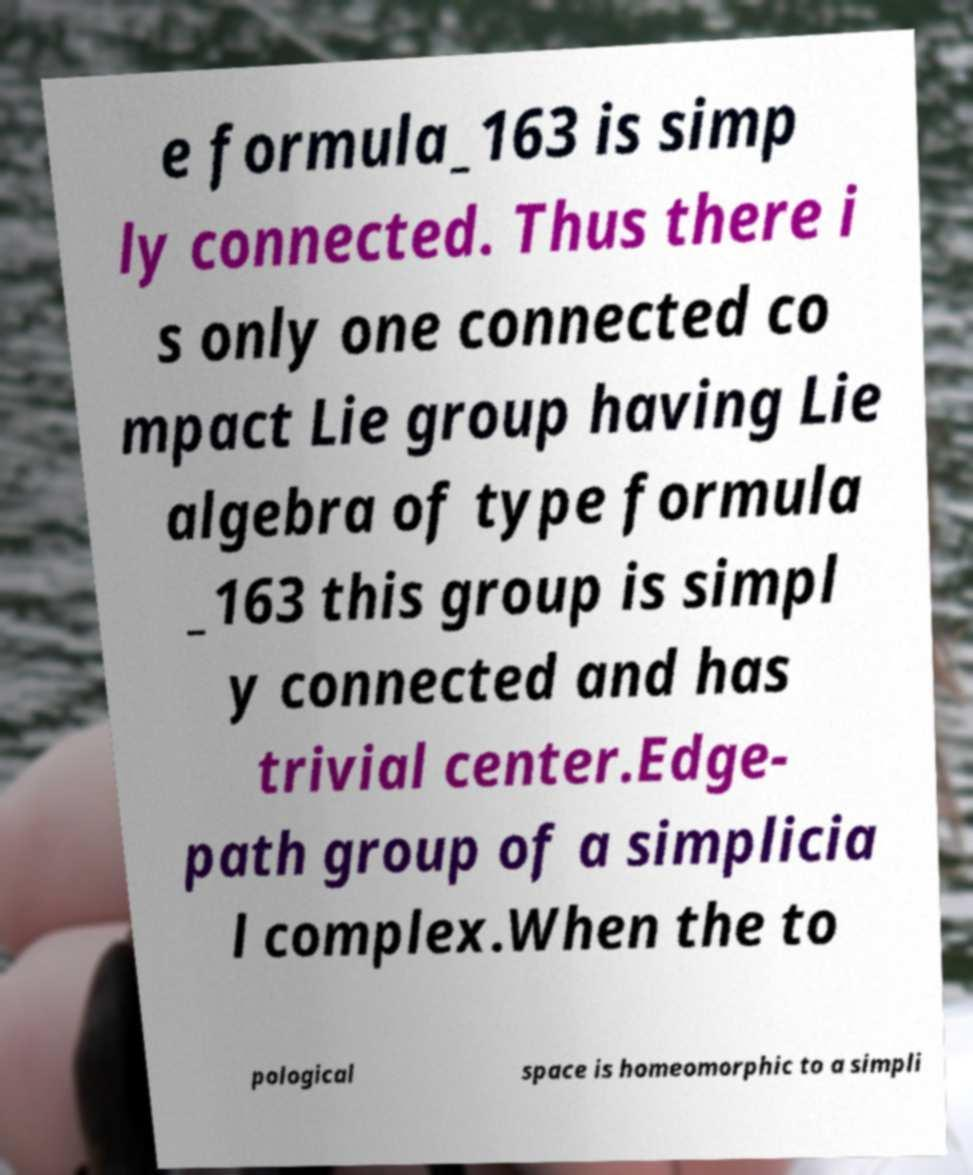Please read and relay the text visible in this image. What does it say? e formula_163 is simp ly connected. Thus there i s only one connected co mpact Lie group having Lie algebra of type formula _163 this group is simpl y connected and has trivial center.Edge- path group of a simplicia l complex.When the to pological space is homeomorphic to a simpli 